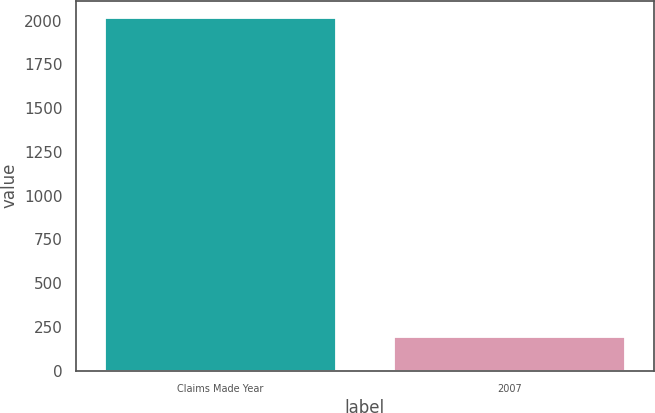Convert chart. <chart><loc_0><loc_0><loc_500><loc_500><bar_chart><fcel>Claims Made Year<fcel>2007<nl><fcel>2014<fcel>190<nl></chart> 